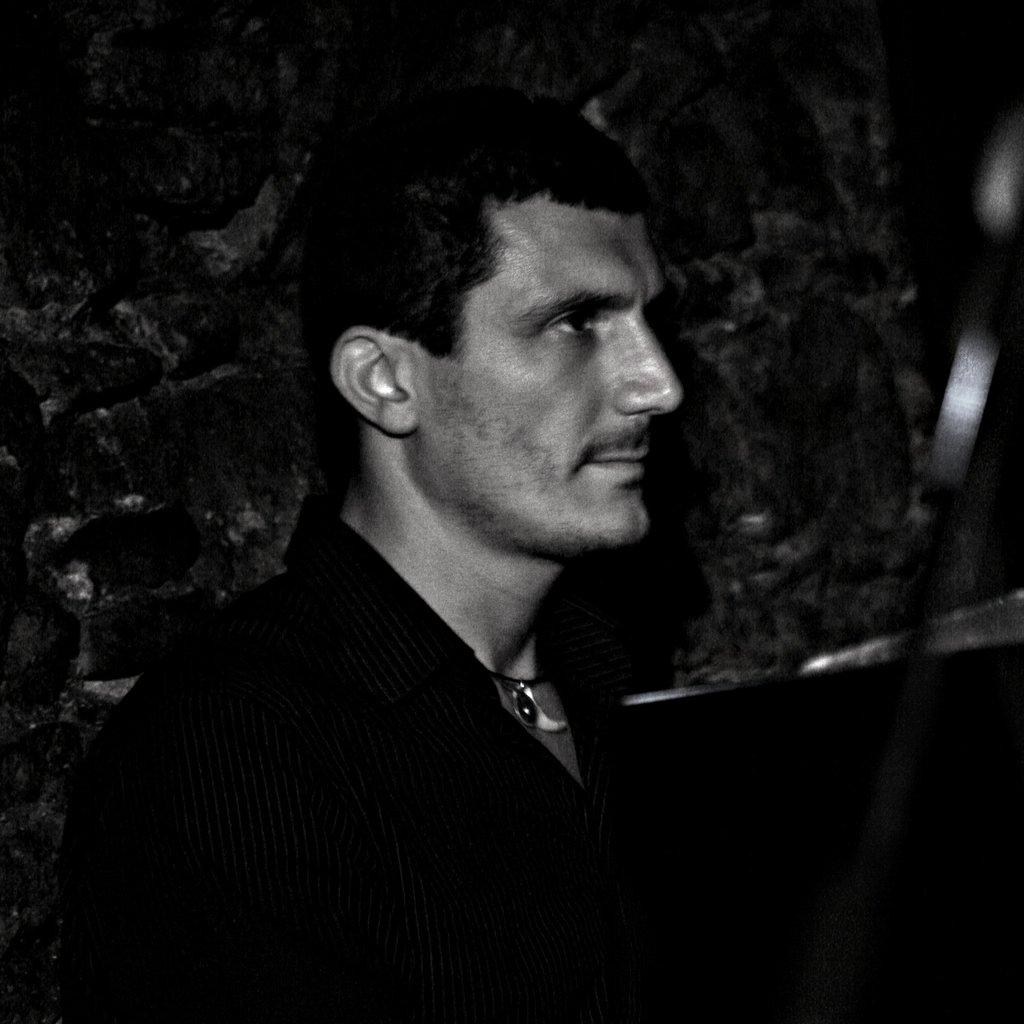What is the color scheme of the image? The image is black and white. Who is present in the image? There is a man in the image. What can be seen in the background of the image? The background of the image includes a wall. What type of instrument is the beggar playing in the image? There is no instrument or beggar present in the image; it features a man in a black and white setting with a wall in the background. 